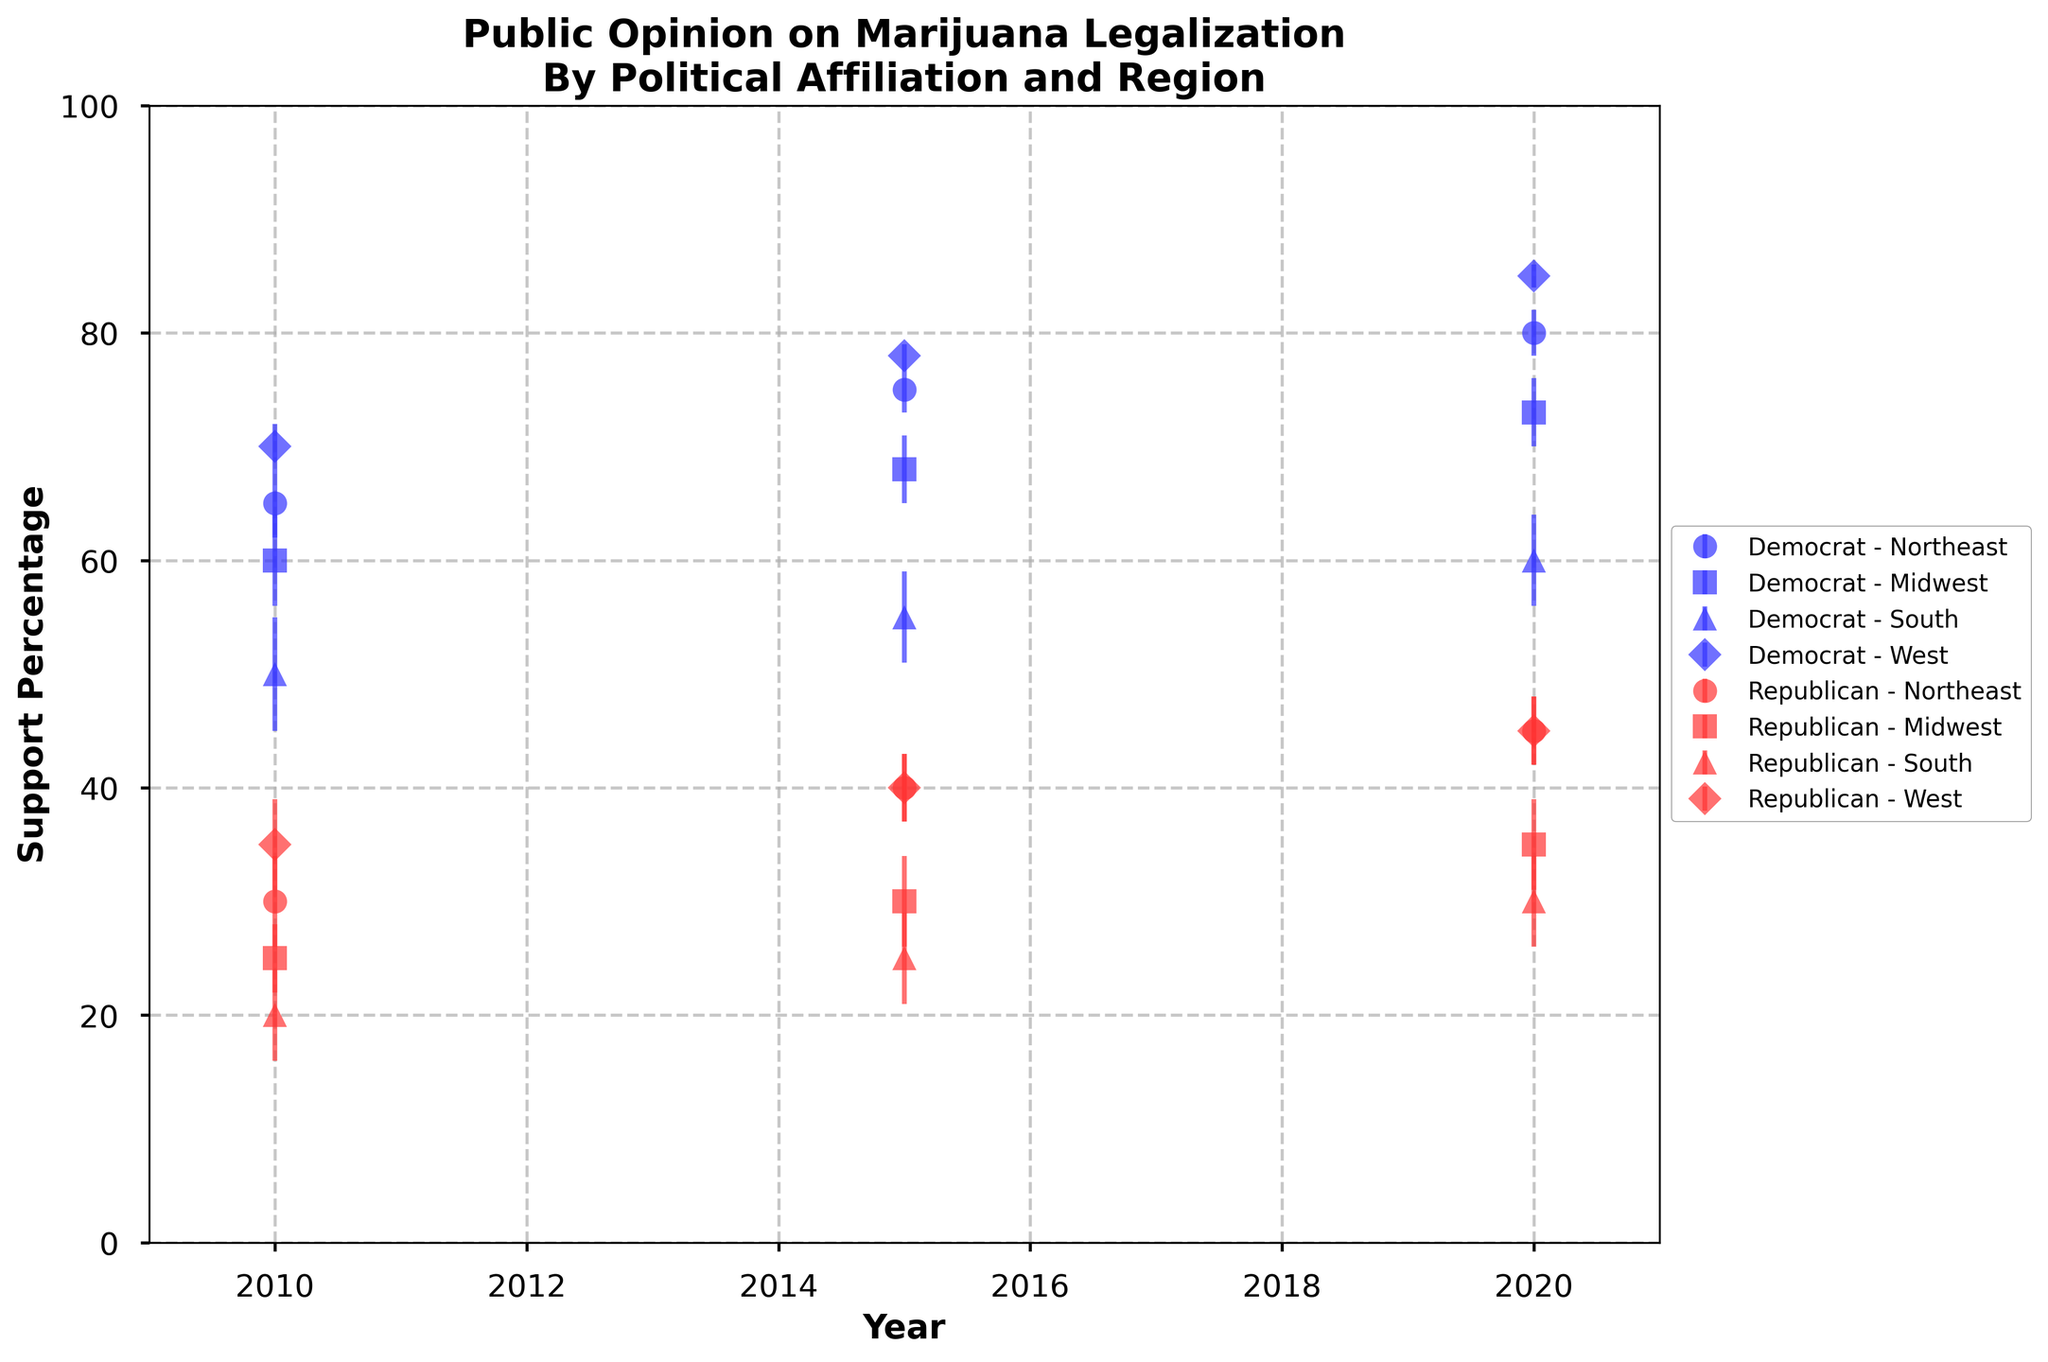What's the title of the figure? The title is usually placed at the top center of the figure in a larger, bold font.
Answer: Public Opinion on Marijuana Legalization By Political Affiliation and Region What is the percentage of support in 2015 for marijuana legalization among Republicans in the Midwest? Find the data point plotted for Republicans in the Midwest for the year 2015. It's around 30% support.
Answer: 30% Which political affiliation showed the highest support for marijuana legalization in the West in 2020? Locate the data points for the West in 2020 and compare the support percentages of Democrats and Republicans. Democrats have the highest support at 85%.
Answer: Democrats By how much did the support percentage for marijuana legalization among Democrats in the Northeast increase from 2010 to 2020? Find the support percentages for Democrats in the Northeast for 2010 (65%) and 2020 (80%) and calculate the difference: 80% - 65%.
Answer: 15% What region and political affiliation had the lowest support for marijuana legalization in 2010? Identify the lowest data point across all regions and affiliations in 2010. It's the South, Republicans, with 20% support.
Answer: South, Republicans What is the trend in support percentage for marijuana legalization among Republicans in the Northeast from 2010 to 2020? Observe the data points for Republicans in the Northeast across the years and note the general direction. It increases from 30% in 2010 to 45% in 2020.
Answer: Increasing What is the approximate average support percentage for marijuana legalization among Democrats in the South over the decade? Average the support percentages for Democrats in the South across 2010 (50%), 2015 (55%), and 2020 (60%). Average = (50 + 55 + 60) / 3 = 55%.
Answer: 55% Which region showed the strongest increase in support for marijuana legalization among Democrats from 2010 to 2020? Compare the increases in support percentages for each region among Democrats from 2010 to 2020. The West increased from 70% to 85%, the highest increase.
Answer: West What is the error margin for the support percentage of Republicans in the Midwest in 2015? Find the error margin depicted by the error bars for Republicans in the Midwest in 2015, which is 4%.
Answer: 4% How does the support for marijuana legalization among Democrats in the West in 2020 compare to Republicans in the same region and year? Compare the data points for Democrats and Republicans in the West for 2020. Democrats have 85% support while Republicans have 45% support.
Answer: Democrats have significantly higher support 